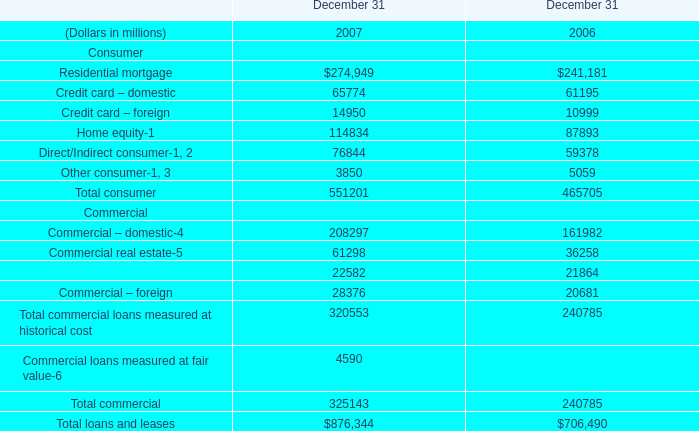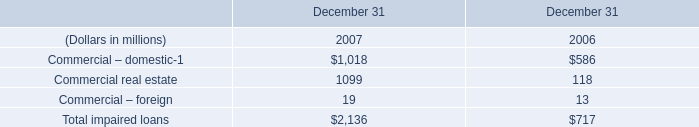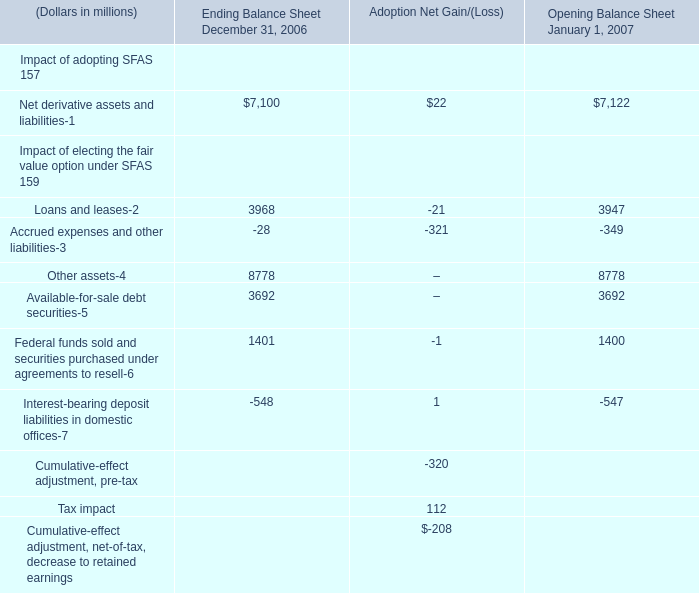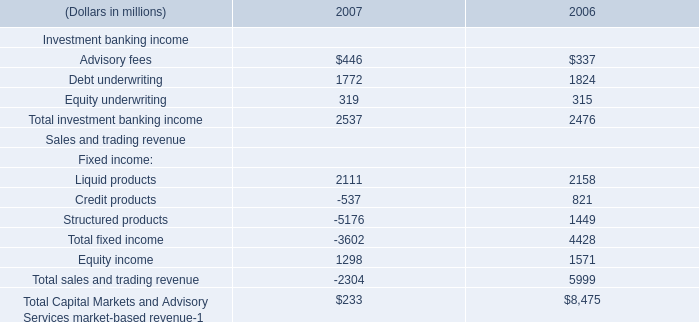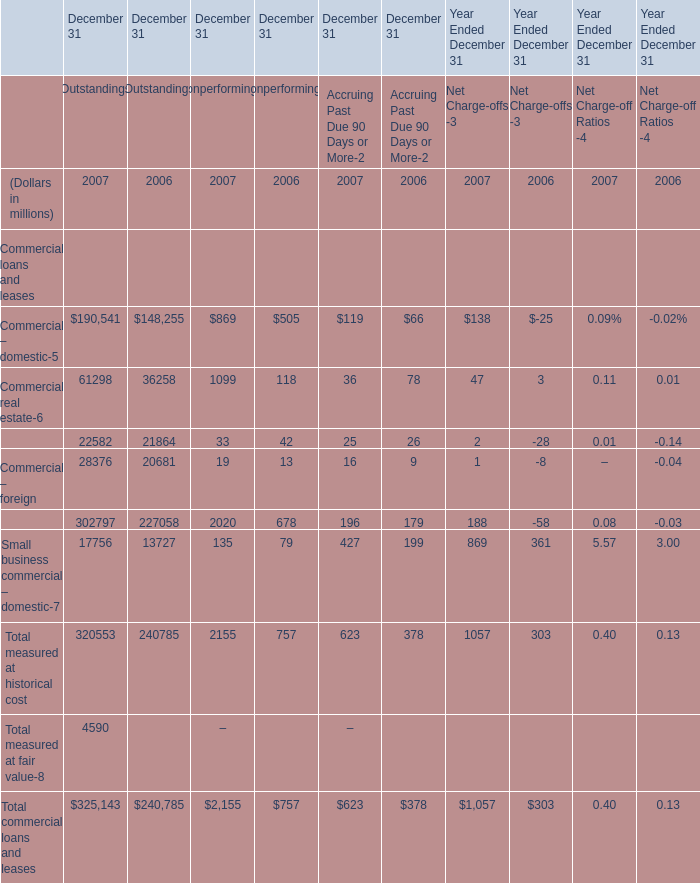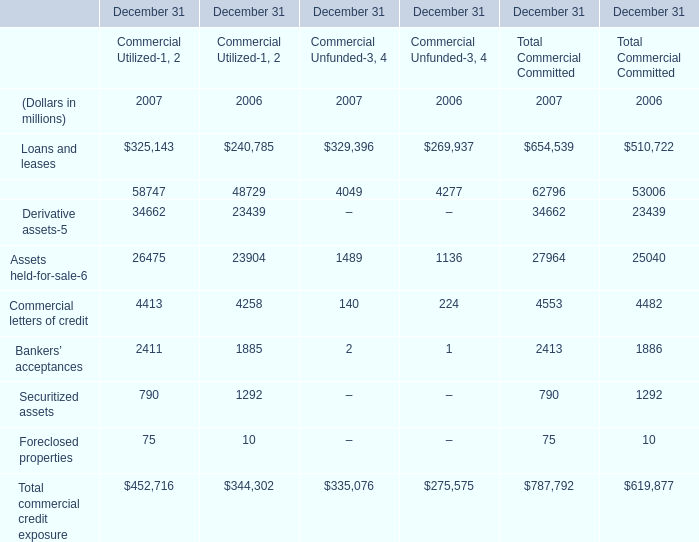What is the proportion of Loans and leases to the total in 2007? 
Computations: (325143 / 654539)
Answer: 0.49675. 